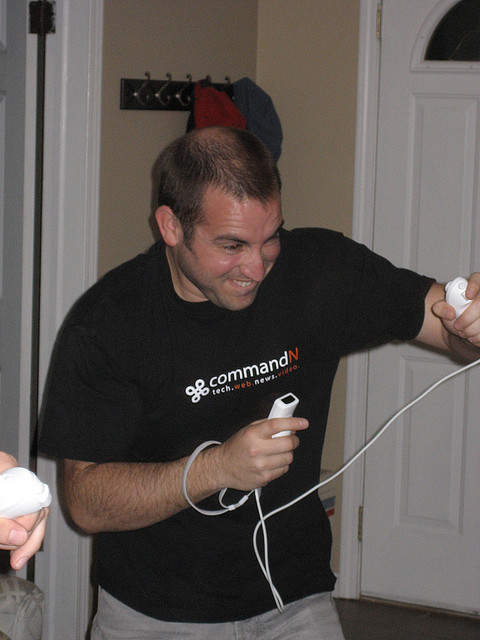Identify and read out the text in this image. commandN LOCH. Web NOWS. video 